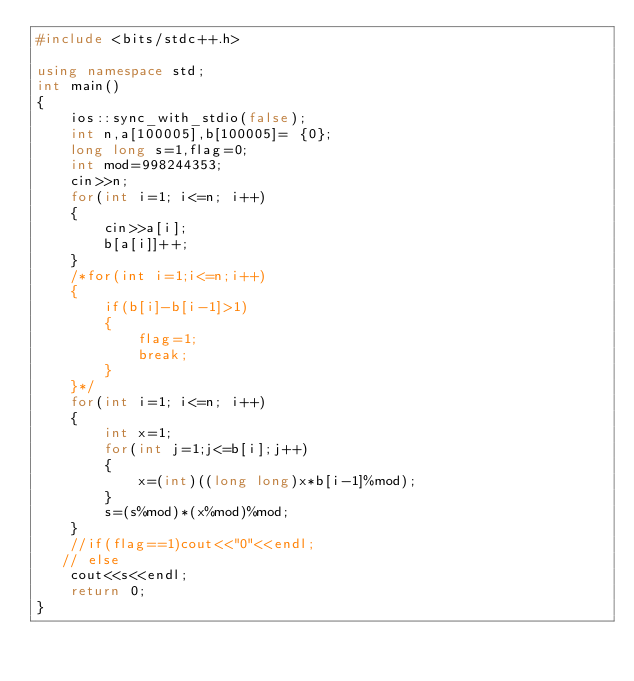Convert code to text. <code><loc_0><loc_0><loc_500><loc_500><_C++_>#include <bits/stdc++.h>

using namespace std;
int main()
{
    ios::sync_with_stdio(false);
    int n,a[100005],b[100005]= {0};
    long long s=1,flag=0;
    int mod=998244353;
    cin>>n;
    for(int i=1; i<=n; i++)
    {
        cin>>a[i];
        b[a[i]]++;
    }
    /*for(int i=1;i<=n;i++)
    {
        if(b[i]-b[i-1]>1)
        {
            flag=1;
            break;
        }
    }*/
    for(int i=1; i<=n; i++)
    {
        int x=1;
        for(int j=1;j<=b[i];j++)
        {
            x=(int)((long long)x*b[i-1]%mod);
        }
        s=(s%mod)*(x%mod)%mod;
    }
    //if(flag==1)cout<<"0"<<endl;
   // else
    cout<<s<<endl;
    return 0;
}
</code> 